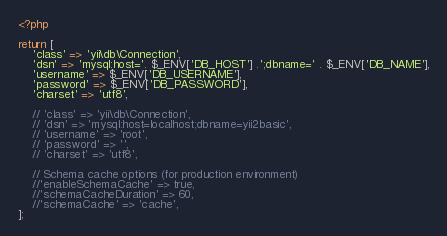<code> <loc_0><loc_0><loc_500><loc_500><_PHP_><?php

return [
    'class' => 'yii\db\Connection',
    'dsn' => 'mysql:host='. $_ENV['DB_HOST'] .';dbname=' . $_ENV['DB_NAME'],
    'username' => $_ENV['DB_USERNAME'],
    'password' => $_ENV['DB_PASSWORD'],
    'charset' => 'utf8',

    // 'class' => 'yii\db\Connection',
    // 'dsn' => 'mysql:host=localhost;dbname=yii2basic',
    // 'username' => 'root',
    // 'password' => '',
    // 'charset' => 'utf8',

    // Schema cache options (for production environment)
    //'enableSchemaCache' => true,
    //'schemaCacheDuration' => 60,
    //'schemaCache' => 'cache',
];
</code> 